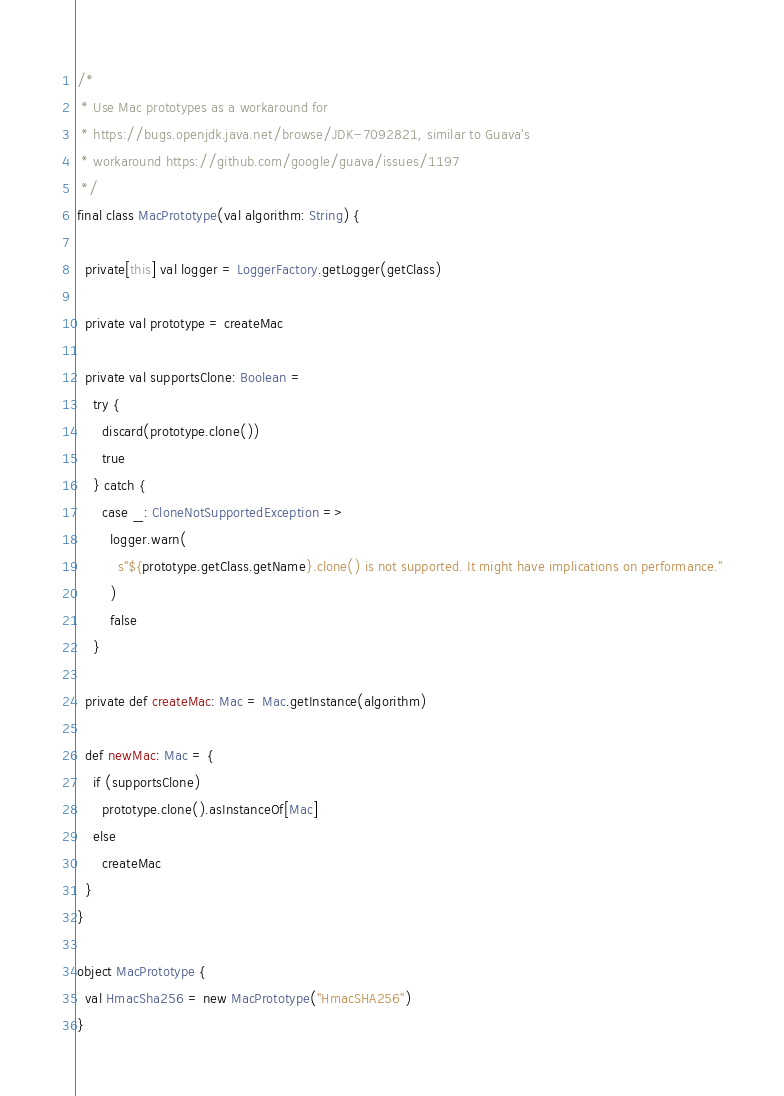<code> <loc_0><loc_0><loc_500><loc_500><_Scala_>/*
 * Use Mac prototypes as a workaround for
 * https://bugs.openjdk.java.net/browse/JDK-7092821, similar to Guava's
 * workaround https://github.com/google/guava/issues/1197
 */
final class MacPrototype(val algorithm: String) {

  private[this] val logger = LoggerFactory.getLogger(getClass)

  private val prototype = createMac

  private val supportsClone: Boolean =
    try {
      discard(prototype.clone())
      true
    } catch {
      case _: CloneNotSupportedException =>
        logger.warn(
          s"${prototype.getClass.getName}.clone() is not supported. It might have implications on performance."
        )
        false
    }

  private def createMac: Mac = Mac.getInstance(algorithm)

  def newMac: Mac = {
    if (supportsClone)
      prototype.clone().asInstanceOf[Mac]
    else
      createMac
  }
}

object MacPrototype {
  val HmacSha256 = new MacPrototype("HmacSHA256")
}
</code> 